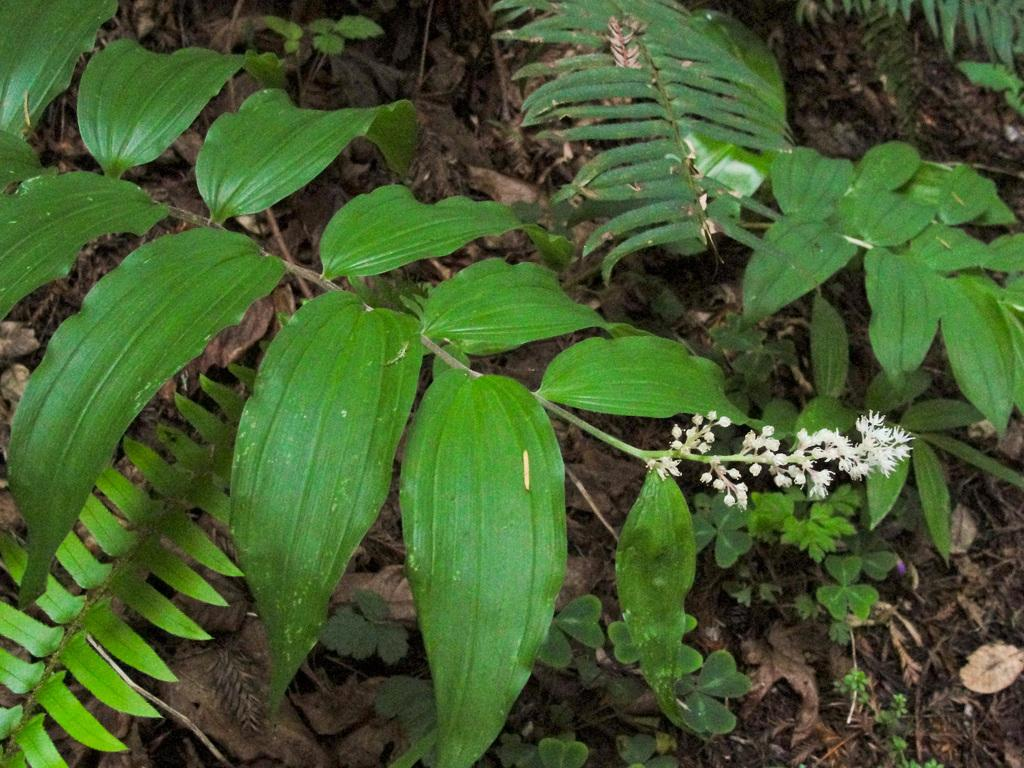What type of living organisms can be seen in the image? Plants and flowers are visible in the image. Are there any signs of the plants' life cycle in the image? Yes, there are dried leaves in the image, which may indicate the end of the plants' life cycle. Can you tell me how many doctors are present in the image? There are no doctors present in the image; it features plants and flowers. What type of wish can be granted by the flowers in the image? The flowers in the image are not associated with granting wishes, as they are simply plants and do not possess magical properties. 